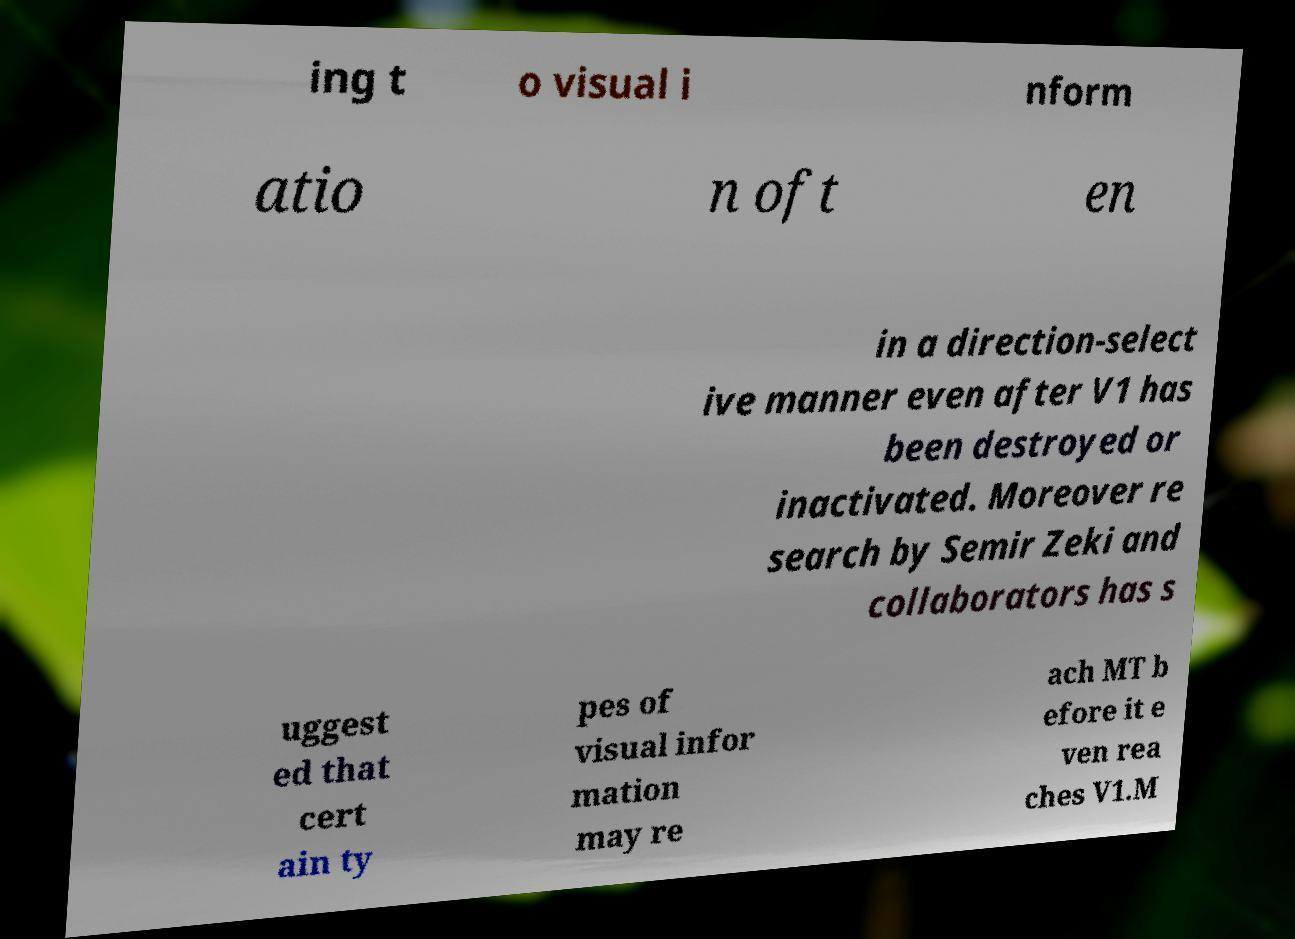There's text embedded in this image that I need extracted. Can you transcribe it verbatim? ing t o visual i nform atio n oft en in a direction-select ive manner even after V1 has been destroyed or inactivated. Moreover re search by Semir Zeki and collaborators has s uggest ed that cert ain ty pes of visual infor mation may re ach MT b efore it e ven rea ches V1.M 